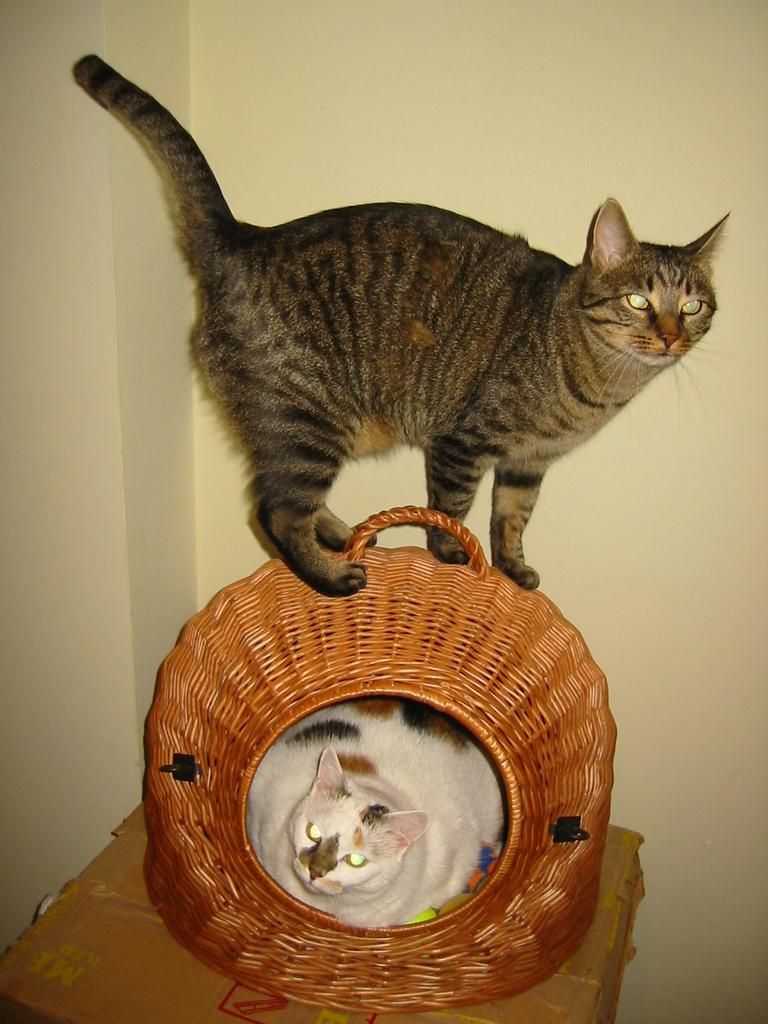What object is present in the image that is typically used for storage or packaging? There is a cardboard box in the image. What type of animal can be seen in a basket in the image? There is a cat in a basket in the image. What is the other cat in the image doing? There is another cat standing on the basket in the image. What can be seen in the background of the image? There is a wall in the background of the image. How many levels of the plant can be seen in the image? There is no plant present in the image. What type of person is visible in the image? There are no people visible in the image; only cats and a cardboard box are present. 